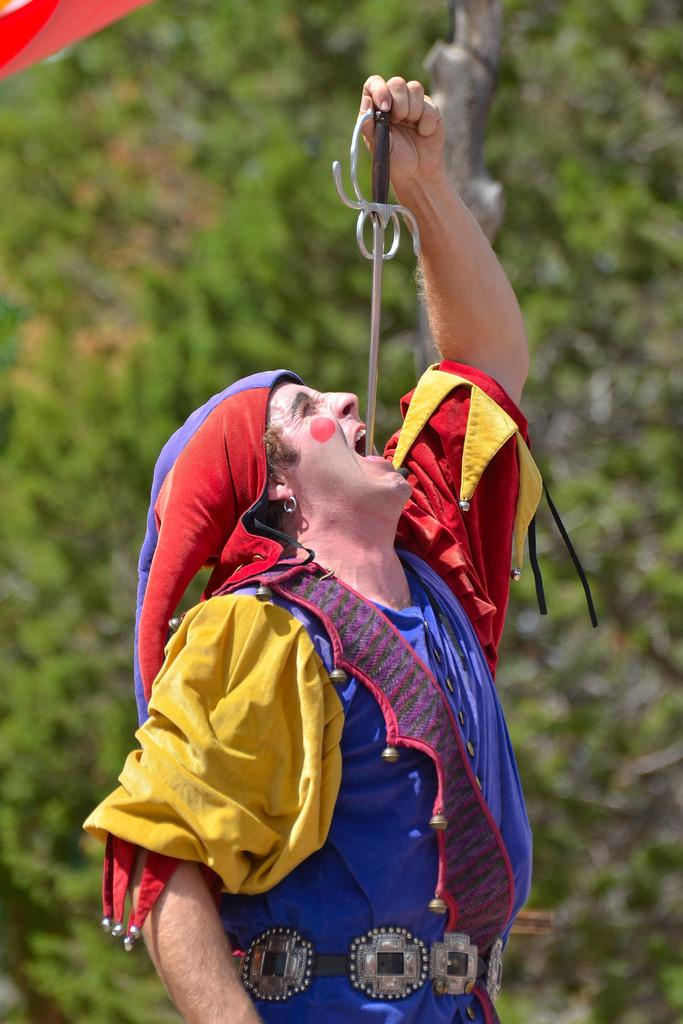What is the main subject in the foreground of the image? There is a person in the foreground of the image. What is the person wearing? The person is wearing a costume. What object is the person holding? The person is holding a stick. What can be seen in the background of the image? There are trees in the background of the image. What language is the pot speaking in the image? There is no pot present in the image, and therefore no language can be attributed to it. 